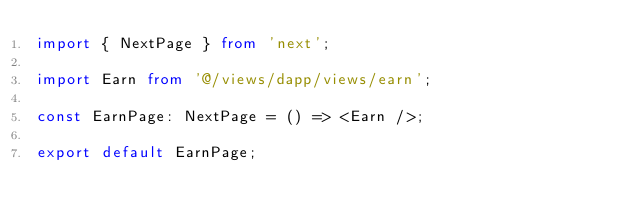Convert code to text. <code><loc_0><loc_0><loc_500><loc_500><_TypeScript_>import { NextPage } from 'next';

import Earn from '@/views/dapp/views/earn';

const EarnPage: NextPage = () => <Earn />;

export default EarnPage;
</code> 